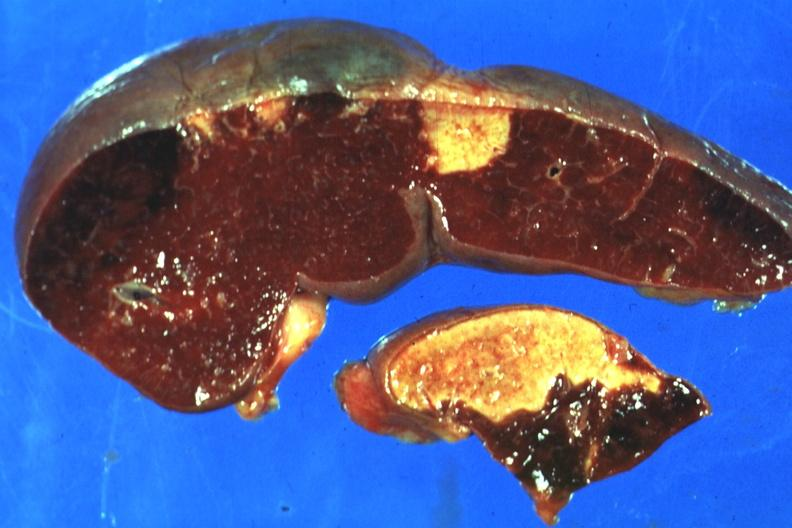what is present?
Answer the question using a single word or phrase. Hematologic 